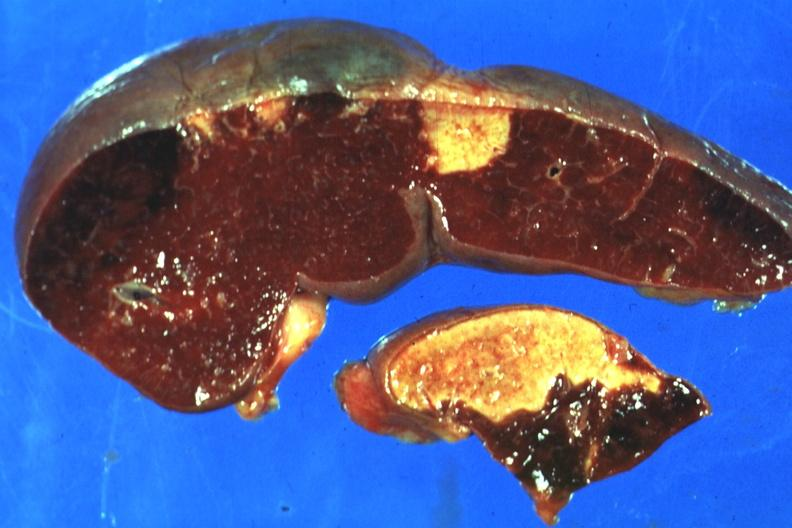what is present?
Answer the question using a single word or phrase. Hematologic 